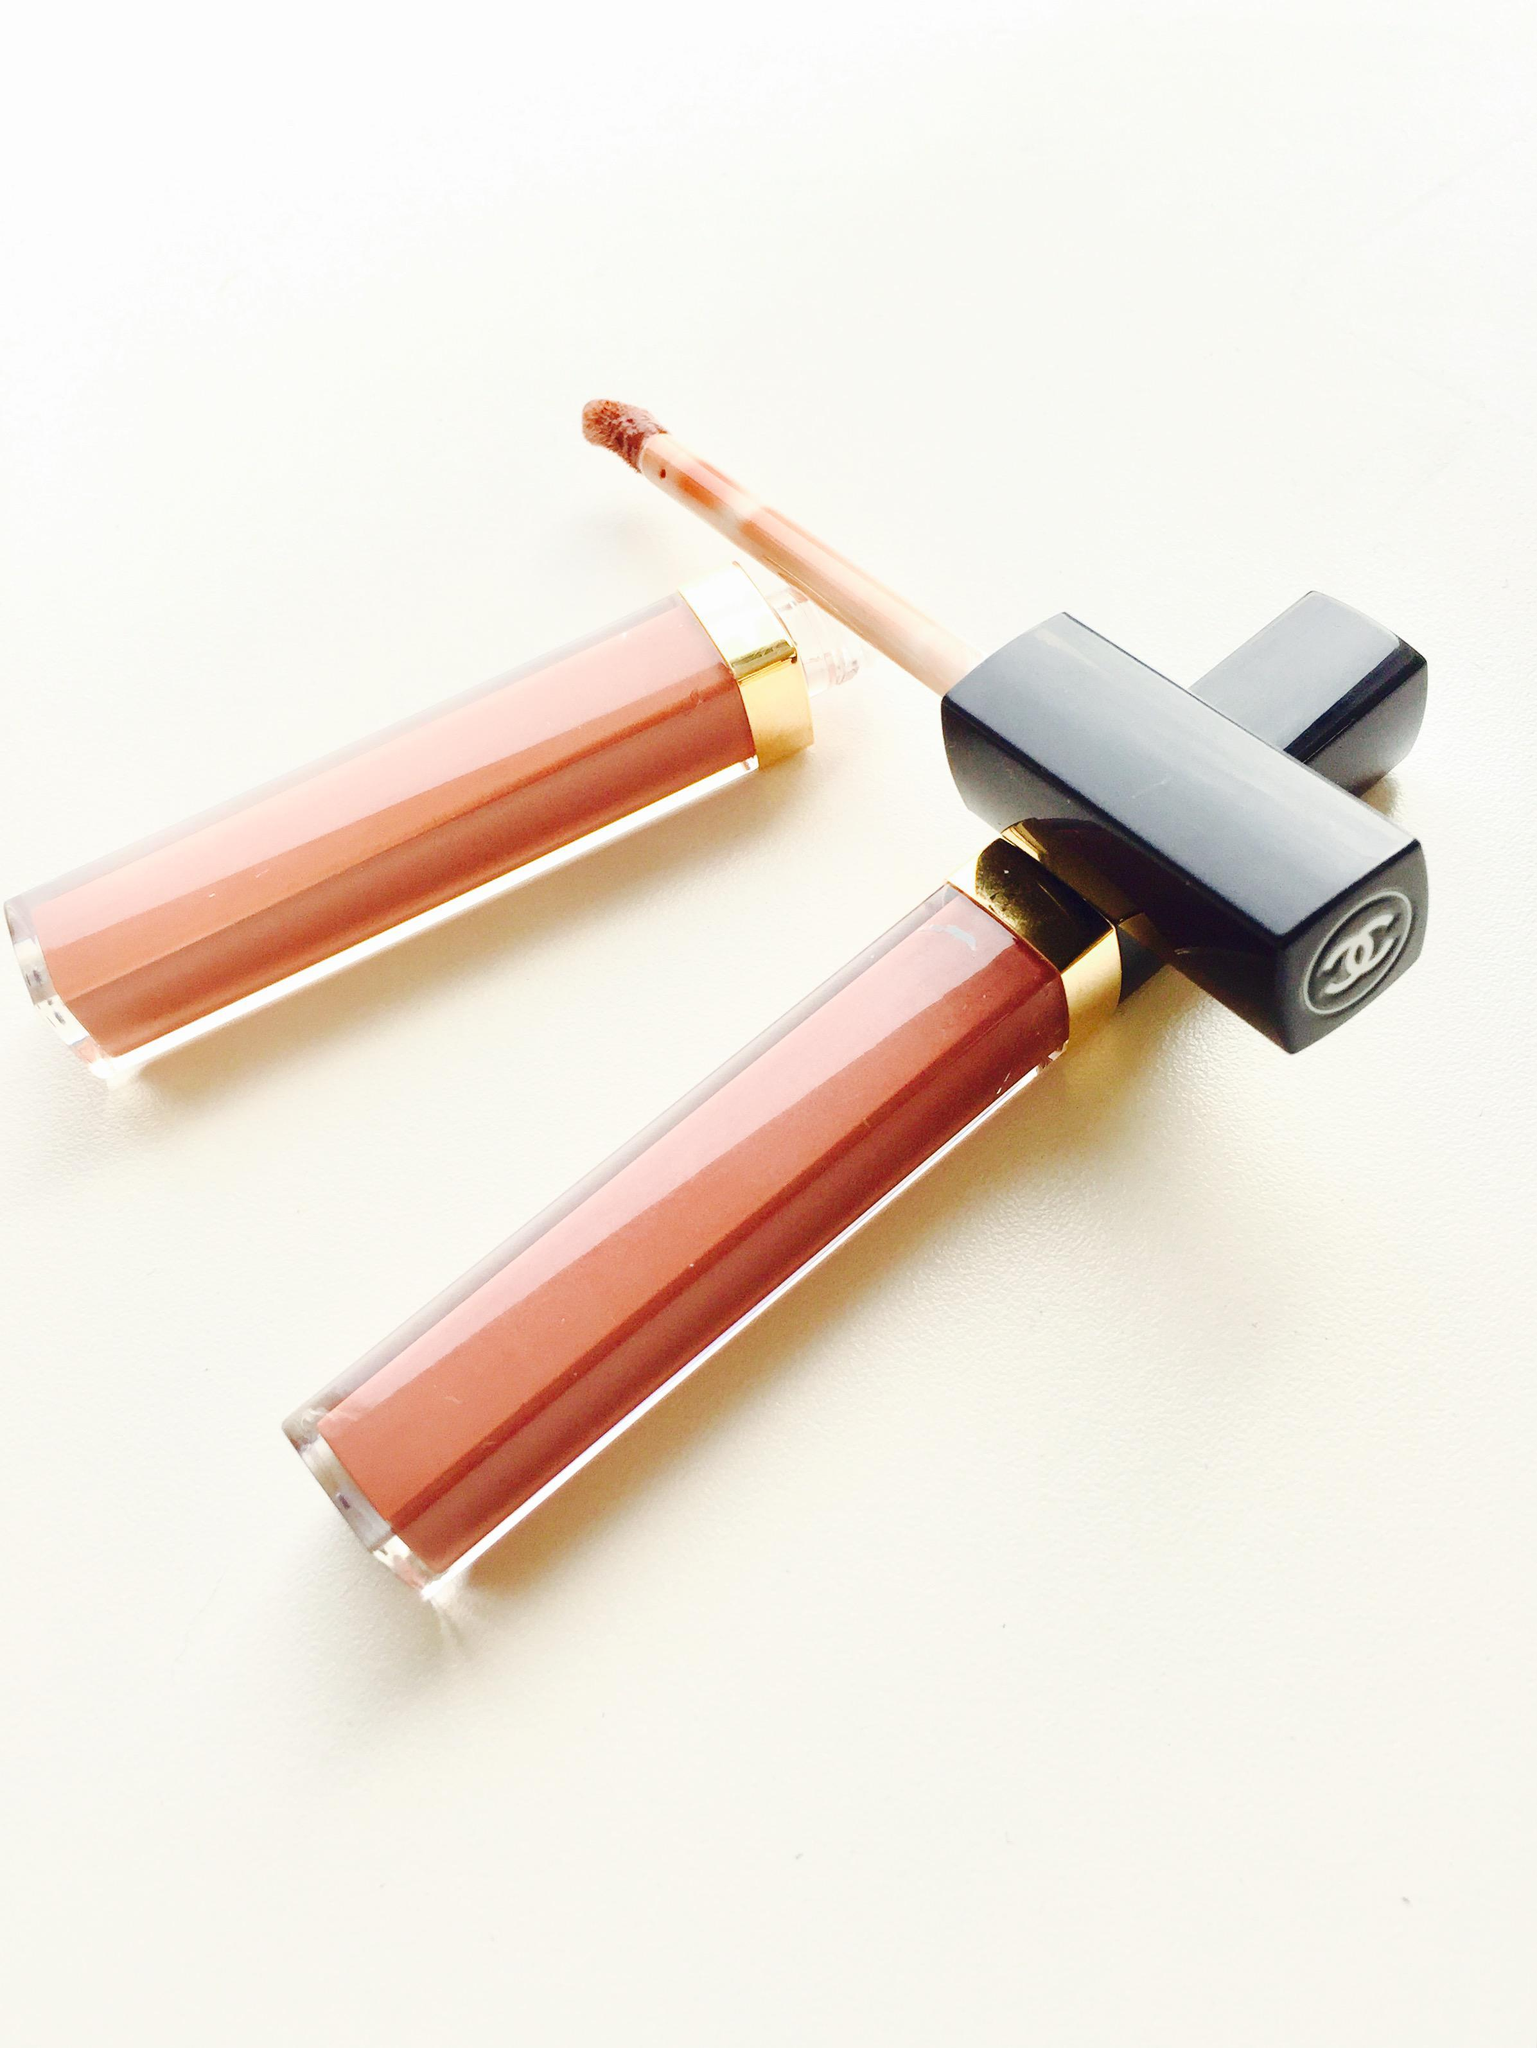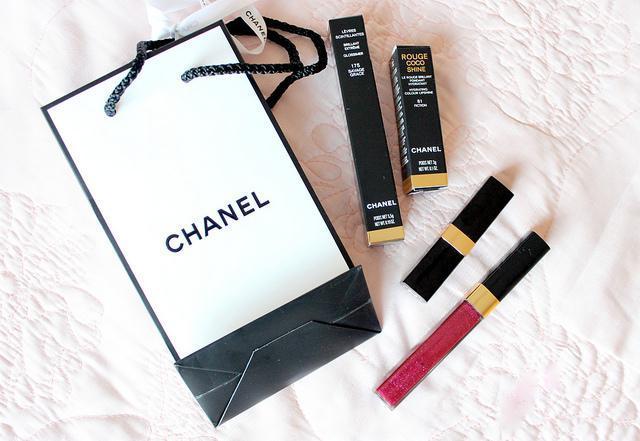The first image is the image on the left, the second image is the image on the right. Evaluate the accuracy of this statement regarding the images: "There are at least 8 different shades of lip gloss in their tubes.". Is it true? Answer yes or no. No. The first image is the image on the left, the second image is the image on the right. Considering the images on both sides, is "The left image includes at least one capped and one uncapped lipstick wand, and the right image includes at least one capped lipstick wand but no uncapped lip makeup." valid? Answer yes or no. Yes. 